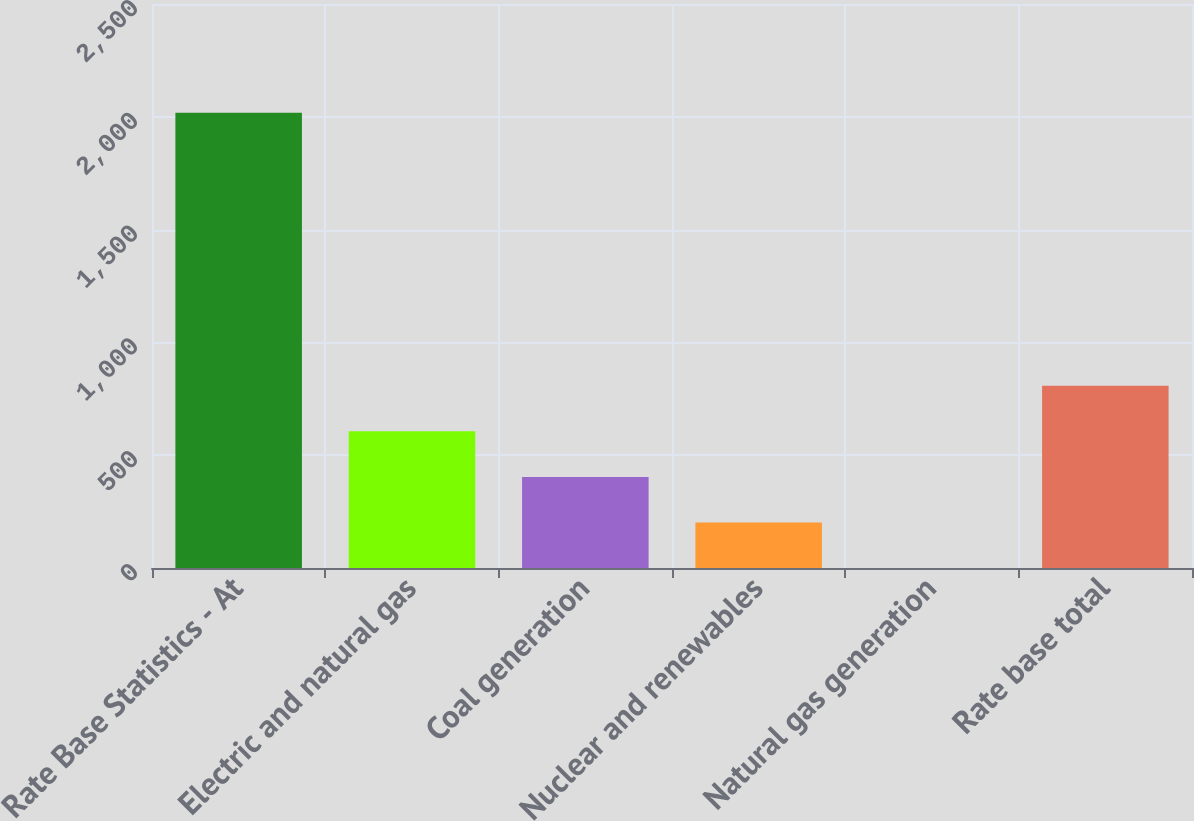Convert chart. <chart><loc_0><loc_0><loc_500><loc_500><bar_chart><fcel>Rate Base Statistics - At<fcel>Electric and natural gas<fcel>Coal generation<fcel>Nuclear and renewables<fcel>Natural gas generation<fcel>Rate base total<nl><fcel>2018<fcel>605.68<fcel>403.92<fcel>202.16<fcel>0.4<fcel>807.44<nl></chart> 